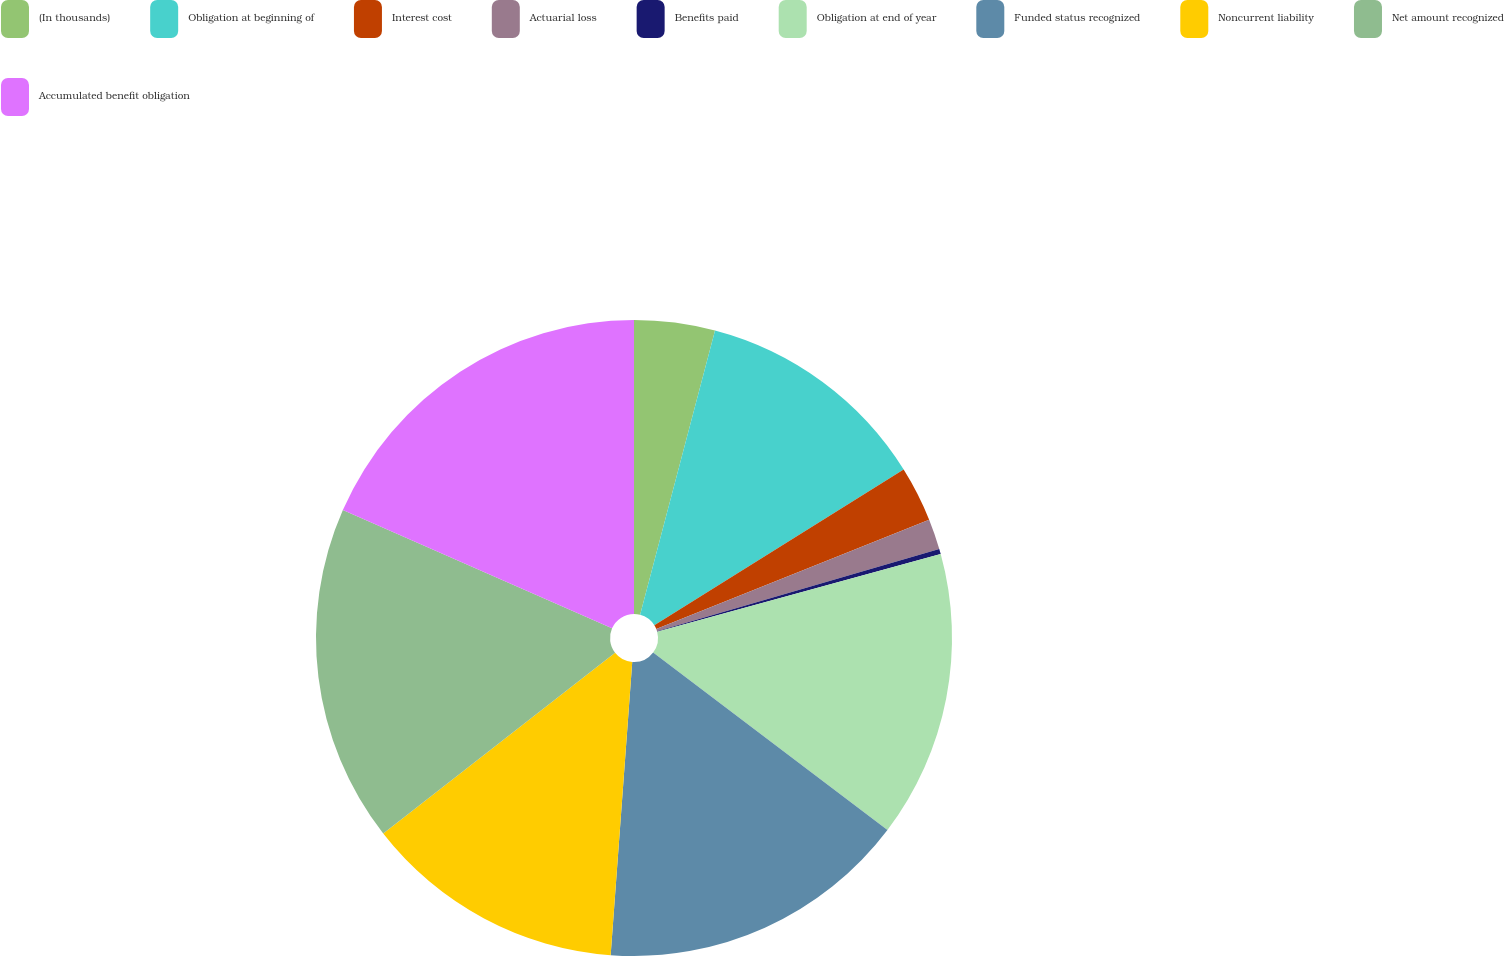Convert chart. <chart><loc_0><loc_0><loc_500><loc_500><pie_chart><fcel>(In thousands)<fcel>Obligation at beginning of<fcel>Interest cost<fcel>Actuarial loss<fcel>Benefits paid<fcel>Obligation at end of year<fcel>Funded status recognized<fcel>Noncurrent liability<fcel>Net amount recognized<fcel>Accumulated benefit obligation<nl><fcel>4.1%<fcel>12.01%<fcel>2.82%<fcel>1.55%<fcel>0.27%<fcel>14.57%<fcel>15.85%<fcel>13.29%<fcel>17.13%<fcel>18.41%<nl></chart> 